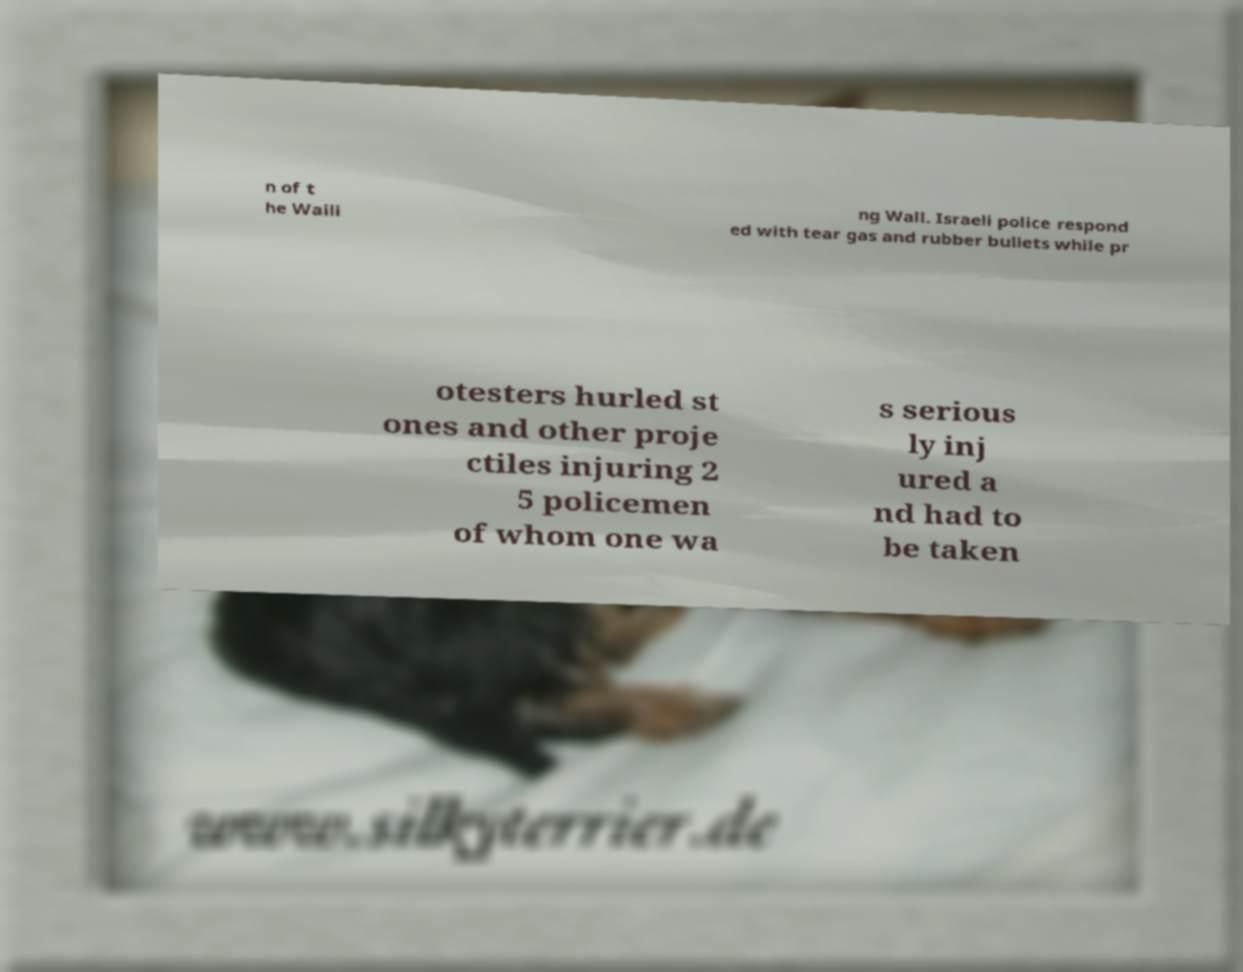Could you extract and type out the text from this image? n of t he Waili ng Wall. Israeli police respond ed with tear gas and rubber bullets while pr otesters hurled st ones and other proje ctiles injuring 2 5 policemen of whom one wa s serious ly inj ured a nd had to be taken 